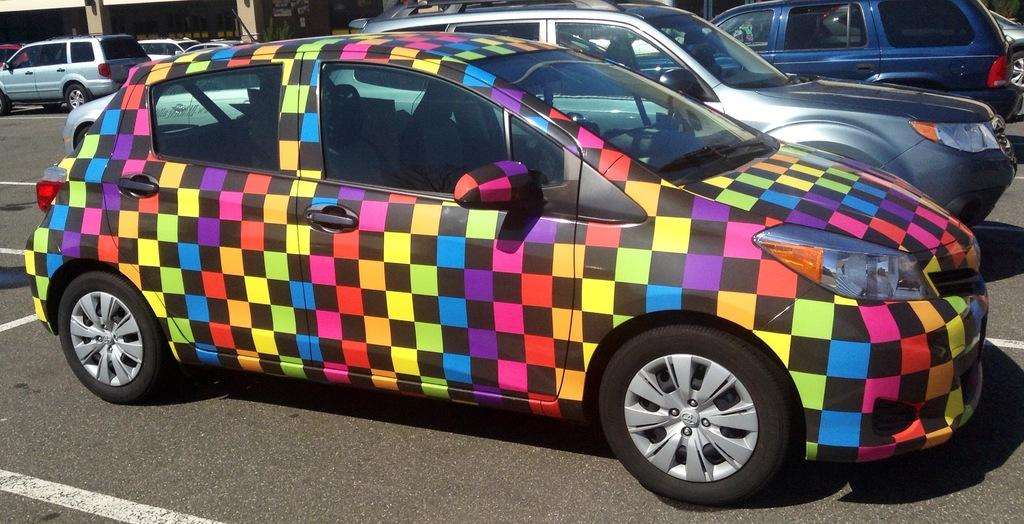What type of vehicles can be seen in the image? There are motor vehicles in the image. Where are the motor vehicles located? The motor vehicles are parked on the road. How are the motor vehicles arranged in the image? The motor vehicles are arranged in rows. How do the dogs move around in the image? There are no dogs present in the image, so this question cannot be answered. 